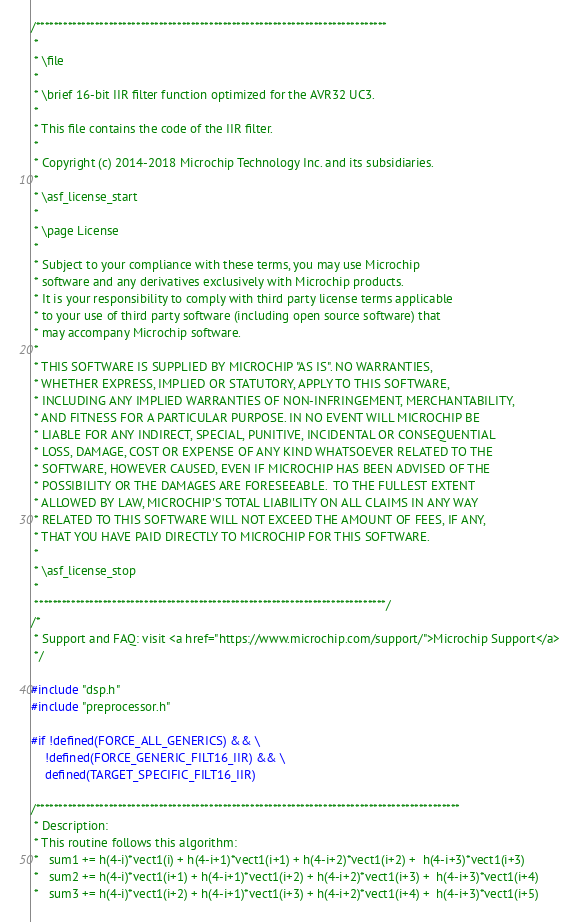<code> <loc_0><loc_0><loc_500><loc_500><_C_>/*****************************************************************************
 *
 * \file
 *
 * \brief 16-bit IIR filter function optimized for the AVR32 UC3.
 *
 * This file contains the code of the IIR filter.
 *
 * Copyright (c) 2014-2018 Microchip Technology Inc. and its subsidiaries.
 *
 * \asf_license_start
 *
 * \page License
 *
 * Subject to your compliance with these terms, you may use Microchip
 * software and any derivatives exclusively with Microchip products.
 * It is your responsibility to comply with third party license terms applicable
 * to your use of third party software (including open source software) that
 * may accompany Microchip software.
 *
 * THIS SOFTWARE IS SUPPLIED BY MICROCHIP "AS IS". NO WARRANTIES,
 * WHETHER EXPRESS, IMPLIED OR STATUTORY, APPLY TO THIS SOFTWARE,
 * INCLUDING ANY IMPLIED WARRANTIES OF NON-INFRINGEMENT, MERCHANTABILITY,
 * AND FITNESS FOR A PARTICULAR PURPOSE. IN NO EVENT WILL MICROCHIP BE
 * LIABLE FOR ANY INDIRECT, SPECIAL, PUNITIVE, INCIDENTAL OR CONSEQUENTIAL
 * LOSS, DAMAGE, COST OR EXPENSE OF ANY KIND WHATSOEVER RELATED TO THE
 * SOFTWARE, HOWEVER CAUSED, EVEN IF MICROCHIP HAS BEEN ADVISED OF THE
 * POSSIBILITY OR THE DAMAGES ARE FORESEEABLE.  TO THE FULLEST EXTENT
 * ALLOWED BY LAW, MICROCHIP'S TOTAL LIABILITY ON ALL CLAIMS IN ANY WAY
 * RELATED TO THIS SOFTWARE WILL NOT EXCEED THE AMOUNT OF FEES, IF ANY,
 * THAT YOU HAVE PAID DIRECTLY TO MICROCHIP FOR THIS SOFTWARE.
 *
 * \asf_license_stop
 *
 *****************************************************************************/
/*
 * Support and FAQ: visit <a href="https://www.microchip.com/support/">Microchip Support</a>
 */

#include "dsp.h"
#include "preprocessor.h"

#if !defined(FORCE_ALL_GENERICS) && \
    !defined(FORCE_GENERIC_FILT16_IIR) && \
    defined(TARGET_SPECIFIC_FILT16_IIR)

/*********************************************************************************************
 * Description:
 * This routine follows this algorithm:
 *   sum1 += h(4-i)*vect1(i) + h(4-i+1)*vect1(i+1) + h(4-i+2)*vect1(i+2) +  h(4-i+3)*vect1(i+3)
 *   sum2 += h(4-i)*vect1(i+1) + h(4-i+1)*vect1(i+2) + h(4-i+2)*vect1(i+3) +  h(4-i+3)*vect1(i+4)
 *   sum3 += h(4-i)*vect1(i+2) + h(4-i+1)*vect1(i+3) + h(4-i+2)*vect1(i+4) +  h(4-i+3)*vect1(i+5)</code> 